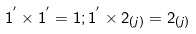Convert formula to latex. <formula><loc_0><loc_0><loc_500><loc_500>1 ^ { ^ { \prime } } \times 1 ^ { ^ { \prime } } = 1 ; 1 ^ { ^ { \prime } } \times 2 _ { ( j ) } = 2 _ { ( j ) }</formula> 